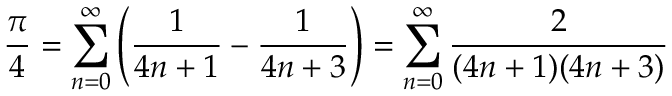Convert formula to latex. <formula><loc_0><loc_0><loc_500><loc_500>{ \frac { \pi } { 4 } } = \sum _ { n = 0 } ^ { \infty } \left ( { \frac { 1 } { 4 n + 1 } } - { \frac { 1 } { 4 n + 3 } } \right ) = \sum _ { n = 0 } ^ { \infty } { \frac { 2 } { ( 4 n + 1 ) ( 4 n + 3 ) } }</formula> 